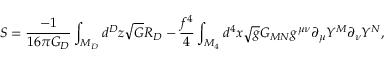<formula> <loc_0><loc_0><loc_500><loc_500>S = \frac { - 1 } { 1 6 \pi G _ { D } } \int _ { M _ { D } } d ^ { D } z \sqrt { G } R _ { D } - \frac { f ^ { 4 } } { 4 } \int _ { M _ { 4 } } d ^ { 4 } x \sqrt { g } G _ { M N } g ^ { \mu \nu } \partial _ { \mu } Y ^ { M } \partial _ { \nu } Y ^ { N } ,</formula> 